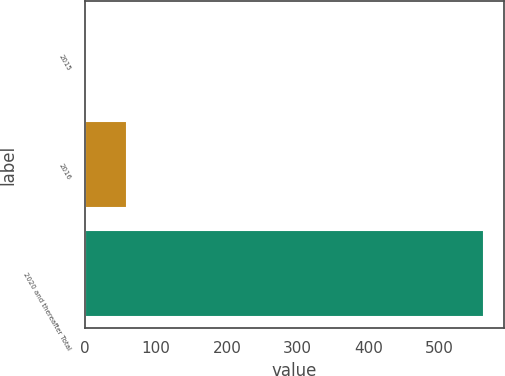Convert chart to OTSL. <chart><loc_0><loc_0><loc_500><loc_500><bar_chart><fcel>2015<fcel>2016<fcel>2020 and thereafter Total<nl><fcel>3.1<fcel>59.06<fcel>562.7<nl></chart> 